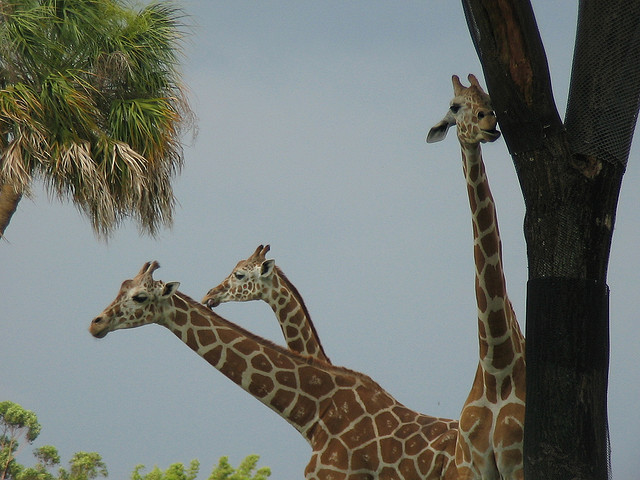<image>Why giraffes stick together? I don't know exactly why giraffes stick together. It could be for family, safety, protection or mating reasons. Is there grass? It's ambiguous whether there is grass or not. Why giraffes stick together? I don't know why giraffes stick together. They may do it for family, safety, protection or mates. Is there grass? I don't know if there is grass. It is ambiguous because some answers say "yes" and some say "no". 